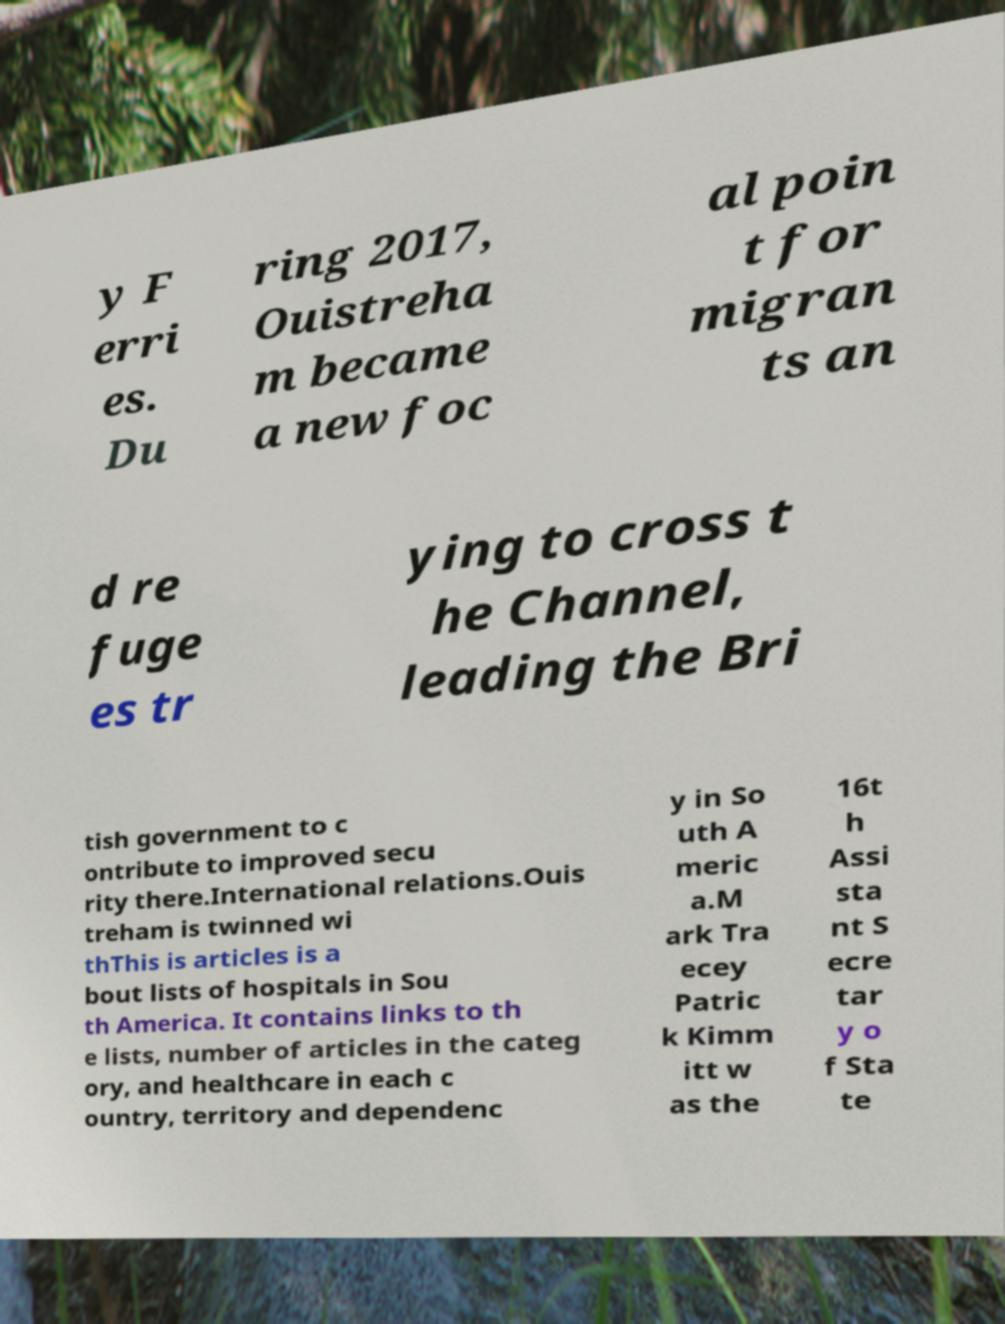Please identify and transcribe the text found in this image. y F erri es. Du ring 2017, Ouistreha m became a new foc al poin t for migran ts an d re fuge es tr ying to cross t he Channel, leading the Bri tish government to c ontribute to improved secu rity there.International relations.Ouis treham is twinned wi thThis is articles is a bout lists of hospitals in Sou th America. It contains links to th e lists, number of articles in the categ ory, and healthcare in each c ountry, territory and dependenc y in So uth A meric a.M ark Tra ecey Patric k Kimm itt w as the 16t h Assi sta nt S ecre tar y o f Sta te 